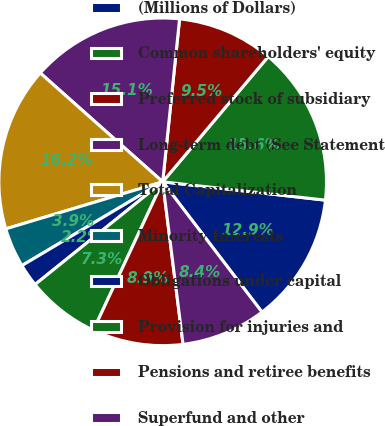Convert chart to OTSL. <chart><loc_0><loc_0><loc_500><loc_500><pie_chart><fcel>(Millions of Dollars)<fcel>Common shareholders' equity<fcel>Preferred stock of subsidiary<fcel>Long-term debt (See Statement<fcel>Total Capitalization<fcel>Minority Interests<fcel>Obligations under capital<fcel>Provision for injuries and<fcel>Pensions and retiree benefits<fcel>Superfund and other<nl><fcel>12.85%<fcel>15.64%<fcel>9.5%<fcel>15.08%<fcel>16.2%<fcel>3.91%<fcel>2.24%<fcel>7.26%<fcel>8.94%<fcel>8.38%<nl></chart> 